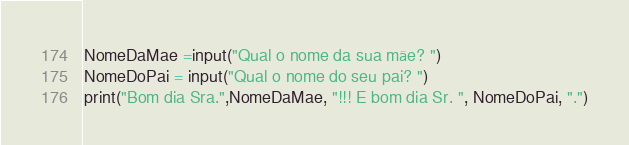Convert code to text. <code><loc_0><loc_0><loc_500><loc_500><_Python_>NomeDaMae =input("Qual o nome da sua mãe? ")
NomeDoPai = input("Qual o nome do seu pai? ")
print("Bom dia Sra.",NomeDaMae, "!!! E bom dia Sr. ", NomeDoPai, ".")</code> 